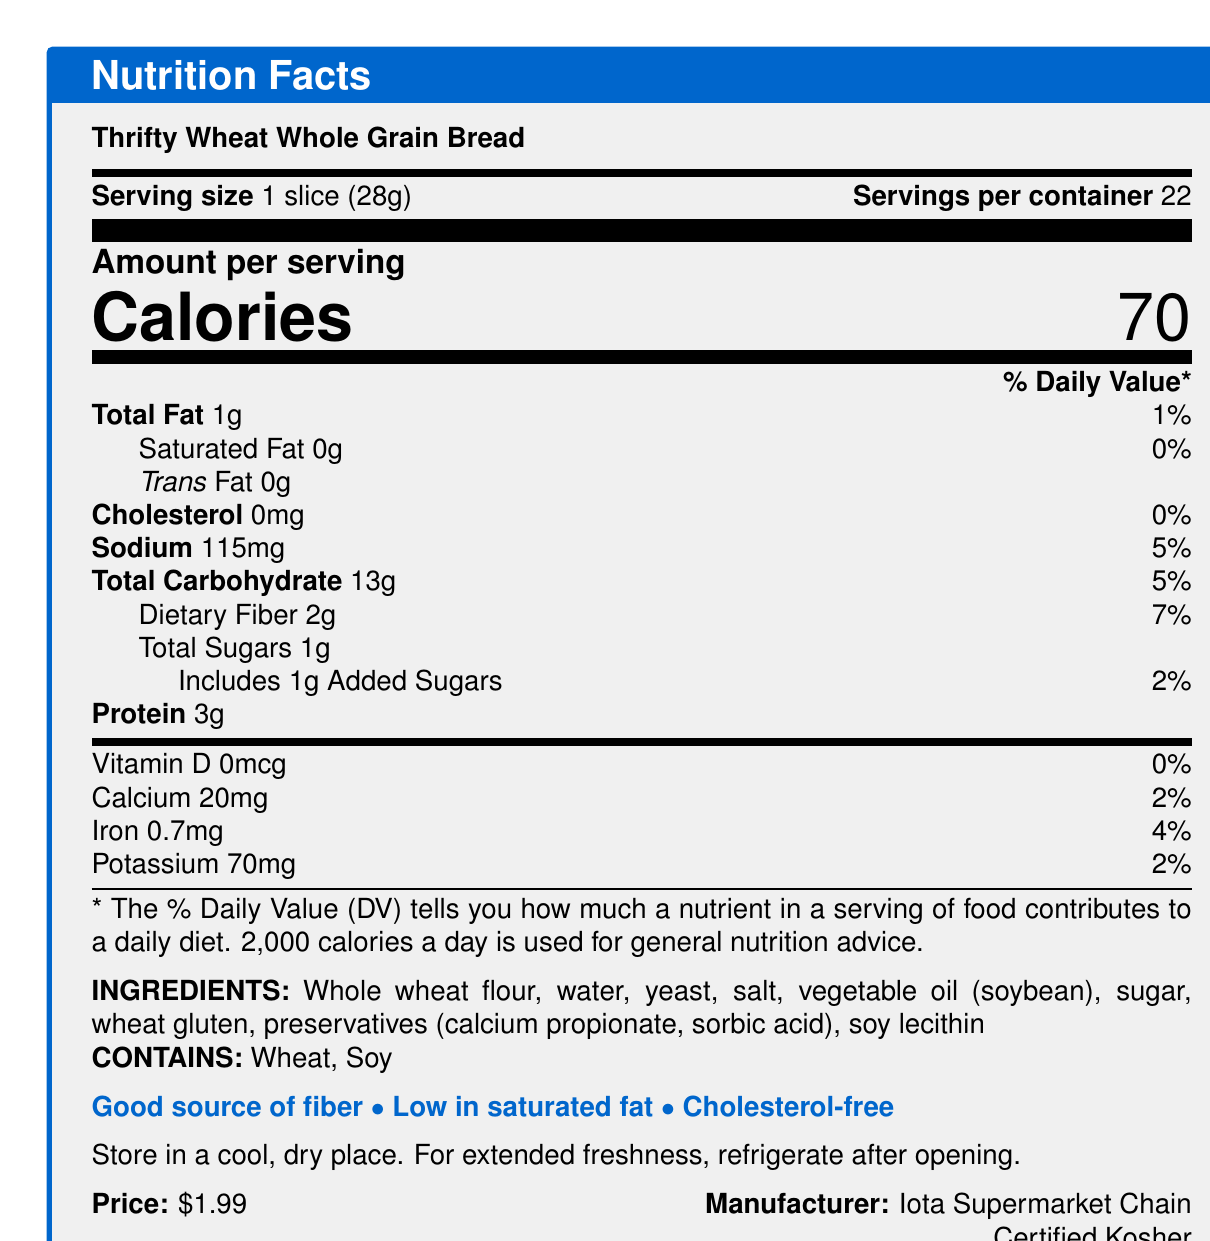what is the serving size? The document lists "Serving size" as 1 slice (28g).
Answer: 1 slice (28g) how many servings are in the container? The document mentions "Servings per container" is 22.
Answer: 22 how many calories are in one serving? The document specifies "Calories" per serving as 70.
Answer: 70 how much dietary fiber is in a serving? The document states "Dietary Fiber" content is 2g per serving.
Answer: 2g what percentage of the daily value of dietary fiber does one serving provide? The document shows "Dietary Fiber" contributes 7% of the daily value per serving.
Answer: 7% what is the total fat content per serving? The document lists "Total Fat" as 1g per serving.
Answer: 1g how much protein is in one serving? The document specifies "Protein" content per serving is 3g.
Answer: 3g how much sodium is in one serving? The document details the "Sodium" content as 115mg per serving.
Answer: 115mg which nutrients are listed as having 0% daily value? A. Saturated Fat, Cholesterol, Vitamin D B. Saturated Fat, Protein, Iron C. Calcium, Iron, Vitamin D The document lists Saturated Fat, Cholesterol, and Vitamin D each with a daily value of 0%.
Answer: A what is the main ingredient in the bread? A. Water B. Yeast C. Whole wheat flour D. Soy lecithin The ingredients list "Whole wheat flour" as the first ingredient, indicating it is the main one.
Answer: C does the product contain any added sugars? The document includes "Includes 1g Added Sugars" under Total Sugars.
Answer: Yes is the bread gluten-free? The document lists "Wheat gluten" in the ingredients, a source of gluten.
Answer: No describe the main points of the document. The document offers essential nutrition facts and ingredient details, emphasizing the bread's health benefits and allergen information.
Answer: The document provides Nutrition Facts for Thrifty Wheat Whole Grain Bread. Key information includes 70 calories per serving, 1g of total fat (1% daily value), and 2g of dietary fiber (7% daily value). The bread is a good source of fiber, low in saturated fat, and cholesterol-free. Ingredients include whole wheat flour, water, yeast, and others, with allergen information noting the presence of wheat and soy. The bread is priced at $1.99 and is produced by Iota Supermarket Chain. how many preservatives are listed in the ingredients? The document lists "preservatives (calcium propionate, sorbic acid)" indicating two preservatives.
Answer: 2 what is the daily value percentage of iron per serving? The document indicates "Iron" has a daily value percentage of 4%.
Answer: 4% can the bread be stored at standard room temperature? The document states to "Store in a cool, dry place."
Answer: Yes who is the manufacturer of the bread? The document lists "Manufacturer: Iota Supermarket Chain."
Answer: Iota Supermarket Chain is the product organic? The document does not provide any information about whether the product is organic.
Answer: Not enough information 